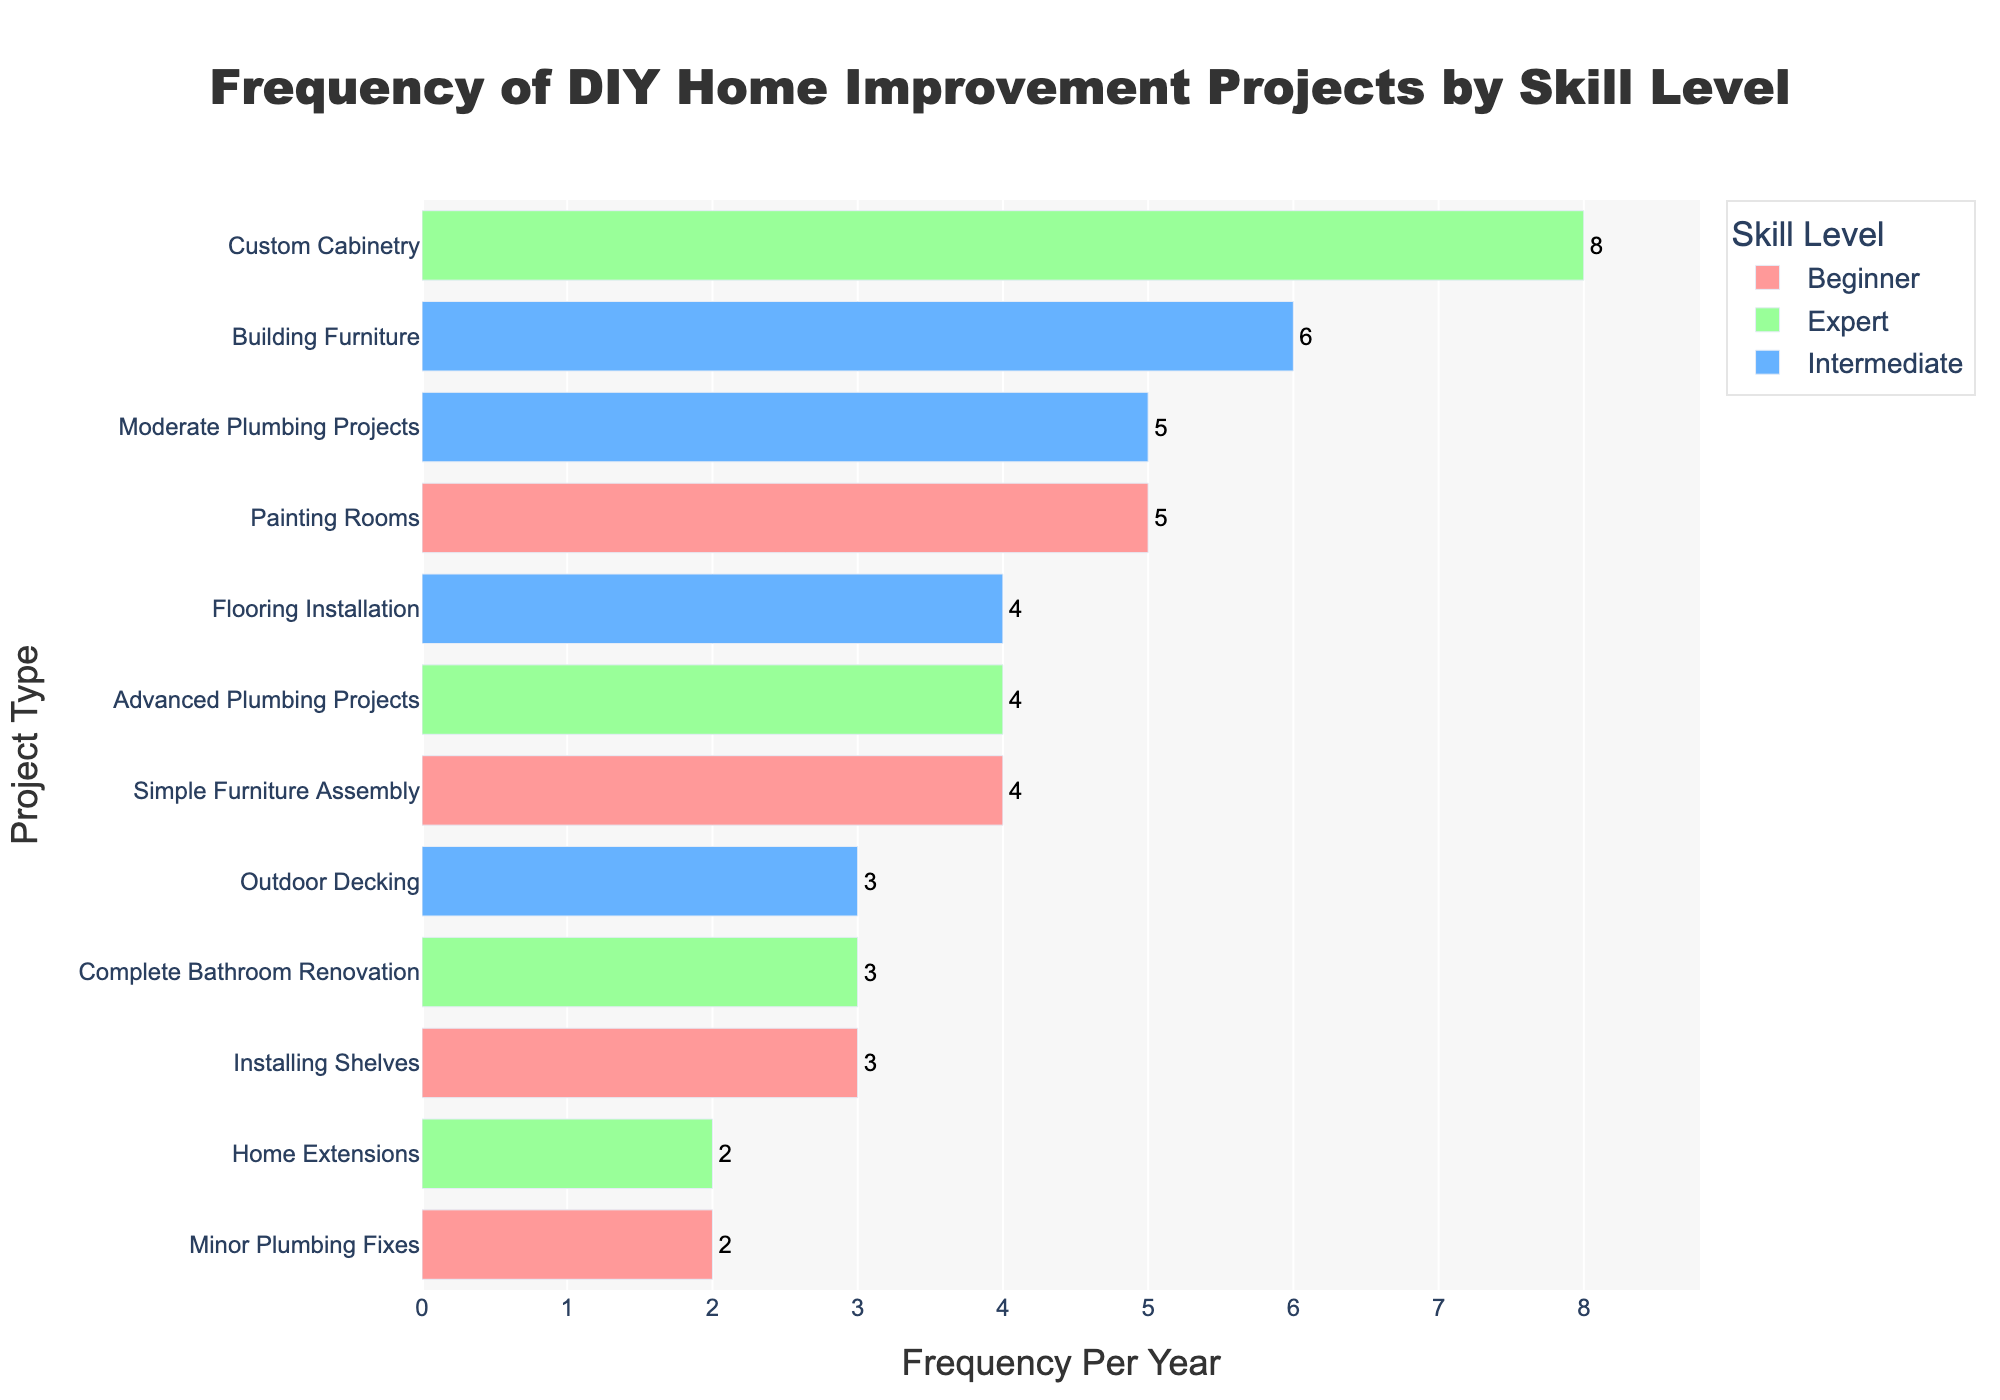What is the most frequent project type undertaken by beginners? The project frequencies for beginners are: Painting Rooms (5), Installing Shelves (3), Simple Furniture Assembly (4), Minor Plumbing Fixes (2). The most frequent is Painting Rooms.
Answer: Painting Rooms How does the frequency of Custom Cabinetry by experts compare to Flooring Installation by intermediates? The frequency of Custom Cabinetry by experts is 8, while the frequency of Flooring Installation by intermediates is 4. Custom Cabinetry is undertaken more frequently.
Answer: Custom Cabinetry by experts Which skill level undertakes Outdoor Decking projects, and how often? Outdoor Decking is categorized under the intermediate skill level, with a frequency of 3 per year.
Answer: Intermediate, 3 What is the sum of frequencies for painting rooms and minor plumbing fixes by beginners? The frequency for Painting Rooms is 5 and Minor Plumbing Fixes is 2. Sum: 5 + 2 = 7.
Answer: 7 Compare the total number of projects undertaken by beginners and experts. Who undertakes more projects? Beginners have a total frequency of 5 + 3 + 4 + 2 = 14. Experts have a total frequency of 8 + 2 + 3 + 4 = 17. Experts undertake more projects.
Answer: Experts Which project type is performed least frequently by intermediates? For intermediates, we have Building Furniture (6), Flooring Installation (4), Outdoor Decking (3), Moderate Plumbing Projects (5). The least frequent project type is Outdoor Decking with 3.
Answer: Outdoor Decking Between Advanced Plumbing Projects by experts and Installing Shelves by beginners, which one is more frequently undertaken? The frequency of Advanced Plumbing Projects by experts is 4, while Installing Shelves by beginners is 3. Advanced Plumbing Projects is more frequently undertaken.
Answer: Advanced Plumbing Projects by experts Among the project types, which one shows a similar frequency for both beginners and experts, and what is that frequency? Checking the frequency of each project type across skill levels, none of the project types undertaken by beginners is mentioned under experts. Hence, there is no common project with a similar frequency.
Answer: None 